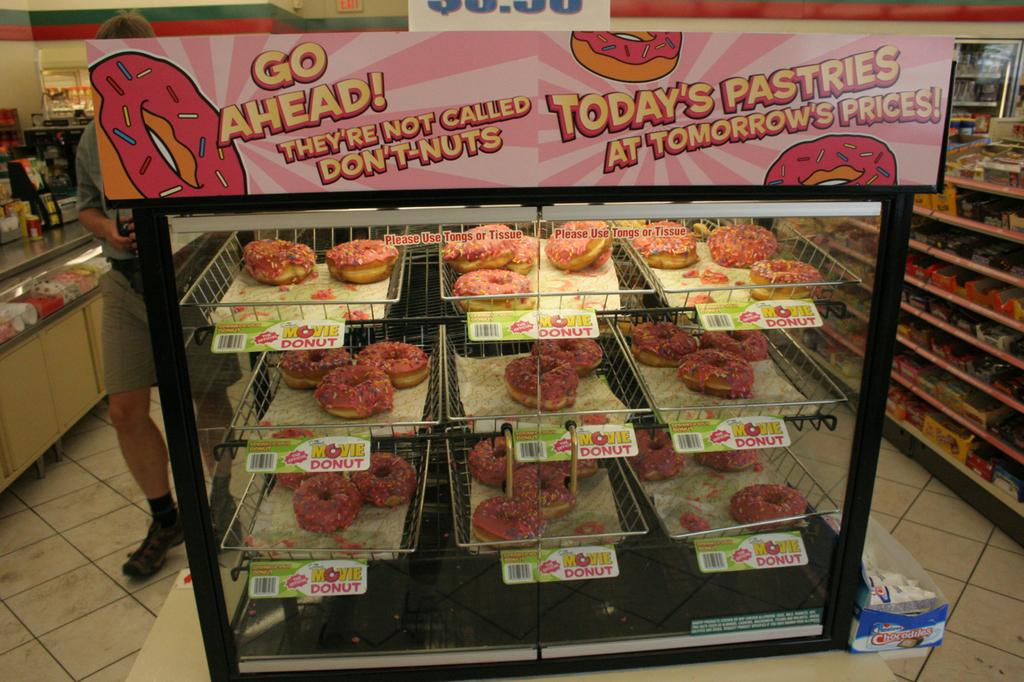Provide a one-sentence caption for the provided image. Pink donuts sold as part of The Simpsons Movies advertising. 